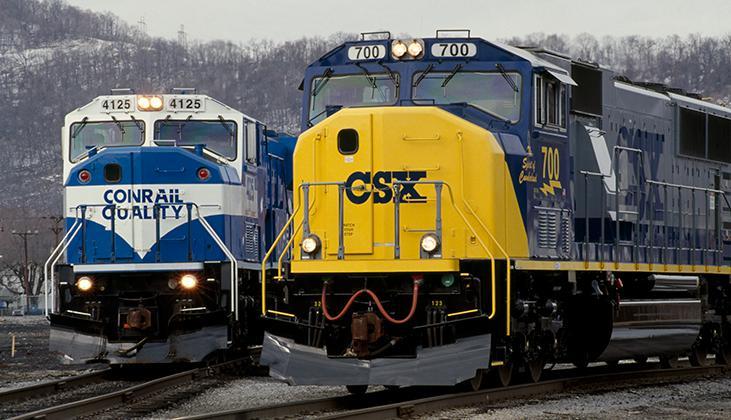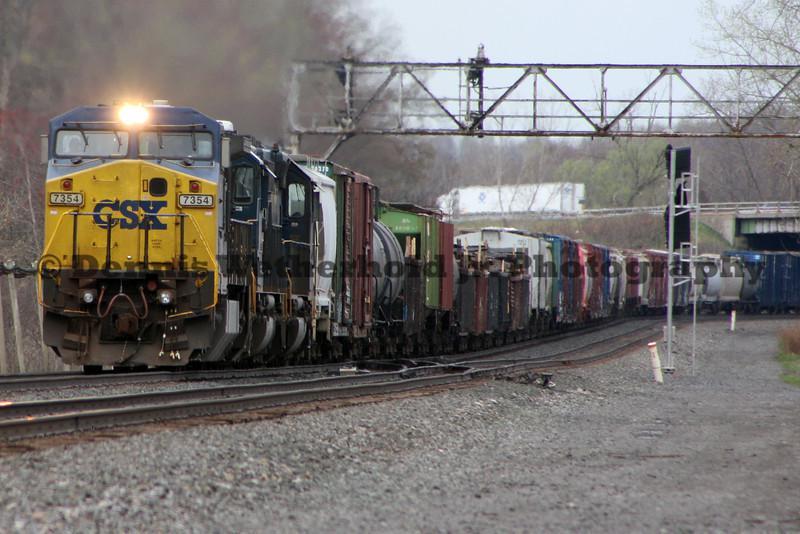The first image is the image on the left, the second image is the image on the right. Examine the images to the left and right. Is the description "Left image shows a blue and yellow train that his heading rightward." accurate? Answer yes or no. No. The first image is the image on the left, the second image is the image on the right. For the images displayed, is the sentence "A total of two trains are headed on the same direction." factually correct? Answer yes or no. No. 